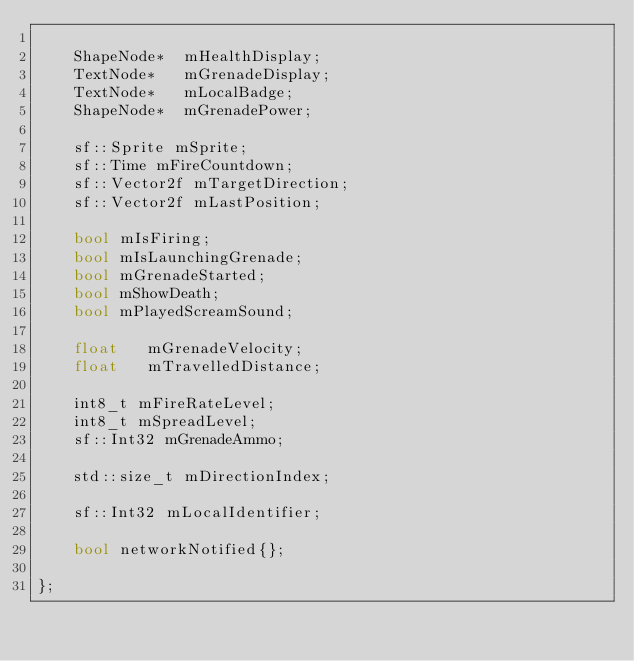<code> <loc_0><loc_0><loc_500><loc_500><_C++_>
	ShapeNode*	mHealthDisplay;
	TextNode*	mGrenadeDisplay;
	TextNode*	mLocalBadge;
	ShapeNode*	mGrenadePower;

	sf::Sprite mSprite;
	sf::Time mFireCountdown;
	sf::Vector2f mTargetDirection;
	sf::Vector2f mLastPosition;

	bool mIsFiring;
	bool mIsLaunchingGrenade;
	bool mGrenadeStarted;
	bool mShowDeath;
	bool mPlayedScreamSound;

	float	mGrenadeVelocity;
	float	mTravelledDistance;

	int8_t mFireRateLevel;
	int8_t mSpreadLevel;
	sf::Int32 mGrenadeAmmo;

	std::size_t mDirectionIndex;

	sf::Int32 mLocalIdentifier;

	bool networkNotified{};

};

</code> 